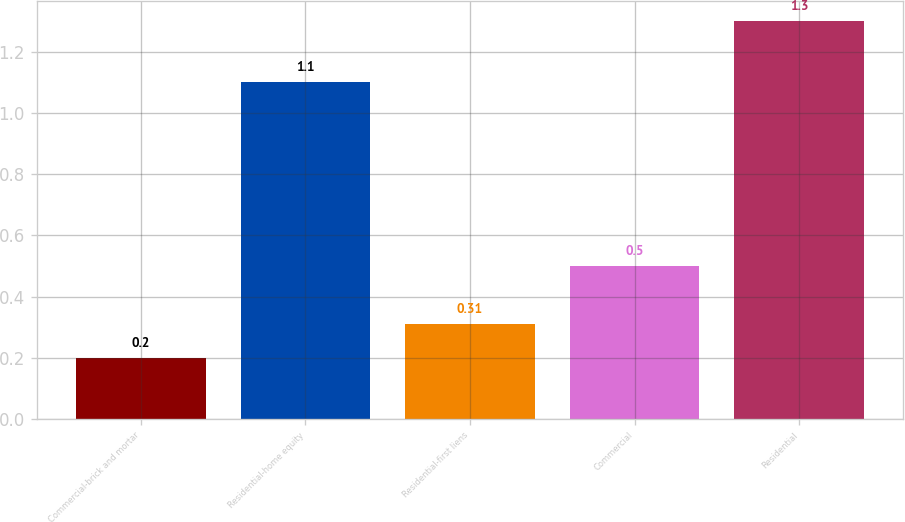<chart> <loc_0><loc_0><loc_500><loc_500><bar_chart><fcel>Commercial-brick and mortar<fcel>Residential-home equity<fcel>Residential-first liens<fcel>Commercial<fcel>Residential<nl><fcel>0.2<fcel>1.1<fcel>0.31<fcel>0.5<fcel>1.3<nl></chart> 